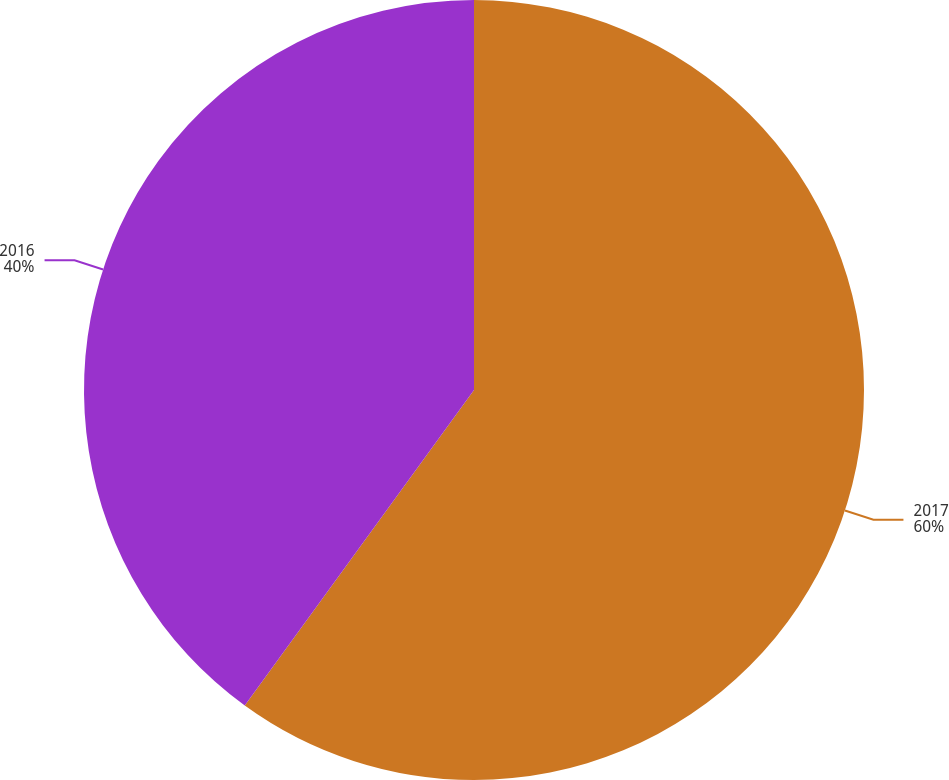Convert chart. <chart><loc_0><loc_0><loc_500><loc_500><pie_chart><fcel>2017<fcel>2016<nl><fcel>60.0%<fcel>40.0%<nl></chart> 